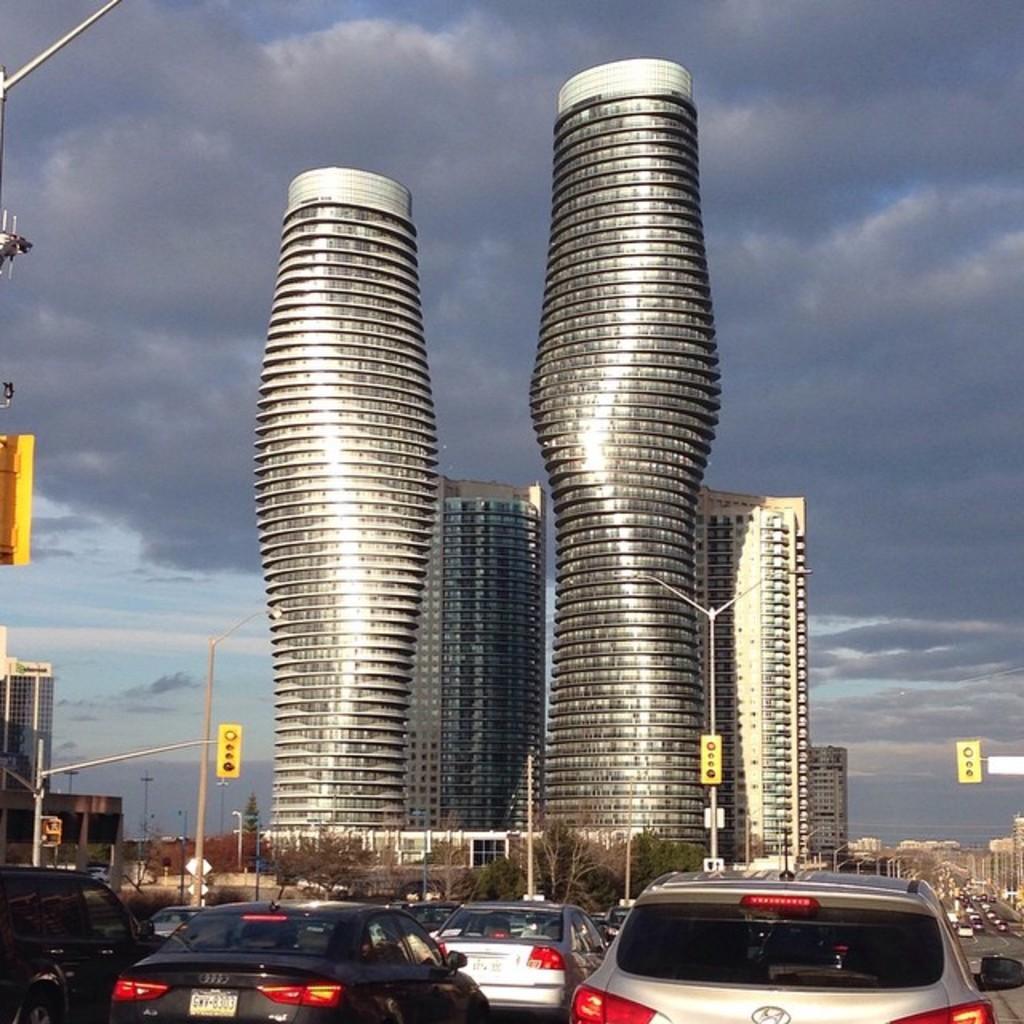Please provide a concise description of this image. In this image I can see number of vehicles, poles, signal lights, buildings, trees, clouds and the sky. 